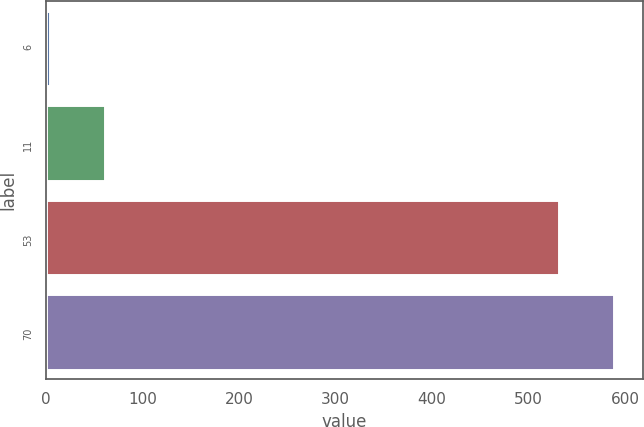Convert chart. <chart><loc_0><loc_0><loc_500><loc_500><bar_chart><fcel>6<fcel>11<fcel>53<fcel>70<nl><fcel>4<fcel>60.8<fcel>532<fcel>588.8<nl></chart> 